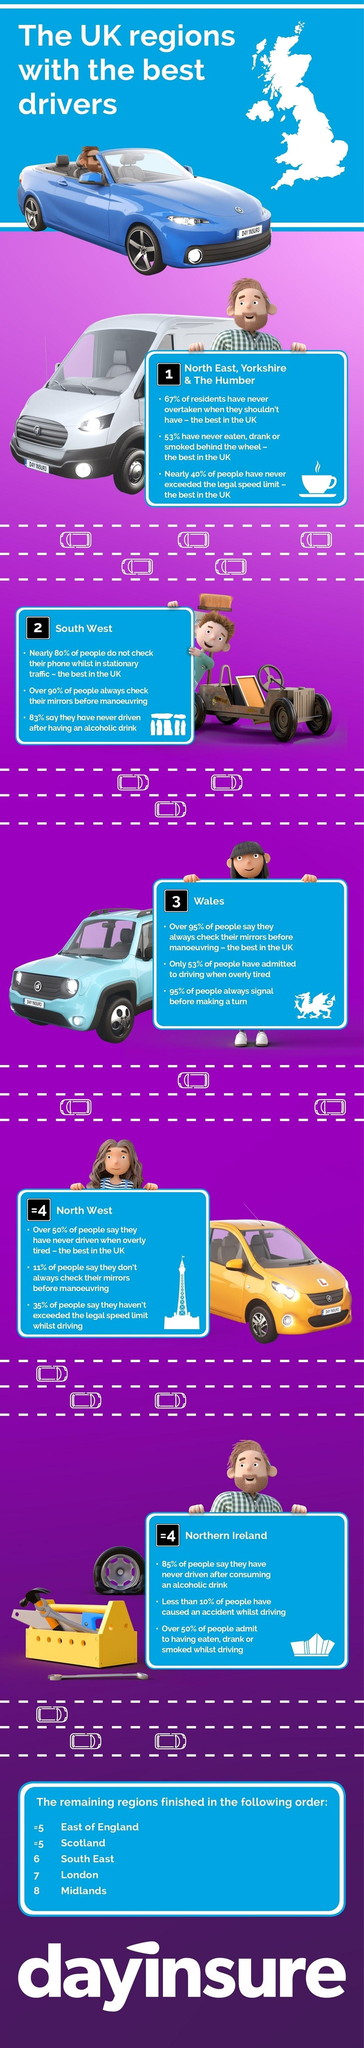Point out several critical features in this image. The North East, Yorkshire & The Humber region is considered the best in the UK for never exceeding the legal speed limit. In the South West region, it was found that 10% of people do not check their mirrors before maneuvering their vehicle. In total, 8 regions in the UK have been ranked. The South West region of the United Kingdom is second-best when it comes to the quality of its drivers, according to a recent study. In the southwest region, 80% of drivers do not check their phones while in stationary traffic. 